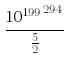Convert formula to latex. <formula><loc_0><loc_0><loc_500><loc_500>\frac { { 1 0 ^ { 1 9 9 } } ^ { 2 9 4 } } { \frac { 5 } { 2 } }</formula> 